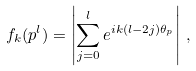Convert formula to latex. <formula><loc_0><loc_0><loc_500><loc_500>f _ { k } ( p ^ { l } ) = \left | \sum _ { j = 0 } ^ { l } e ^ { i k ( l - 2 j ) \theta _ { p } } \right | \, ,</formula> 